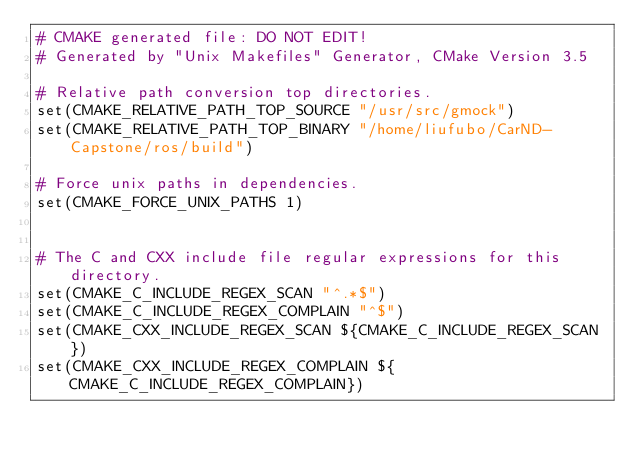<code> <loc_0><loc_0><loc_500><loc_500><_CMake_># CMAKE generated file: DO NOT EDIT!
# Generated by "Unix Makefiles" Generator, CMake Version 3.5

# Relative path conversion top directories.
set(CMAKE_RELATIVE_PATH_TOP_SOURCE "/usr/src/gmock")
set(CMAKE_RELATIVE_PATH_TOP_BINARY "/home/liufubo/CarND-Capstone/ros/build")

# Force unix paths in dependencies.
set(CMAKE_FORCE_UNIX_PATHS 1)


# The C and CXX include file regular expressions for this directory.
set(CMAKE_C_INCLUDE_REGEX_SCAN "^.*$")
set(CMAKE_C_INCLUDE_REGEX_COMPLAIN "^$")
set(CMAKE_CXX_INCLUDE_REGEX_SCAN ${CMAKE_C_INCLUDE_REGEX_SCAN})
set(CMAKE_CXX_INCLUDE_REGEX_COMPLAIN ${CMAKE_C_INCLUDE_REGEX_COMPLAIN})
</code> 